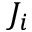<formula> <loc_0><loc_0><loc_500><loc_500>J _ { i }</formula> 